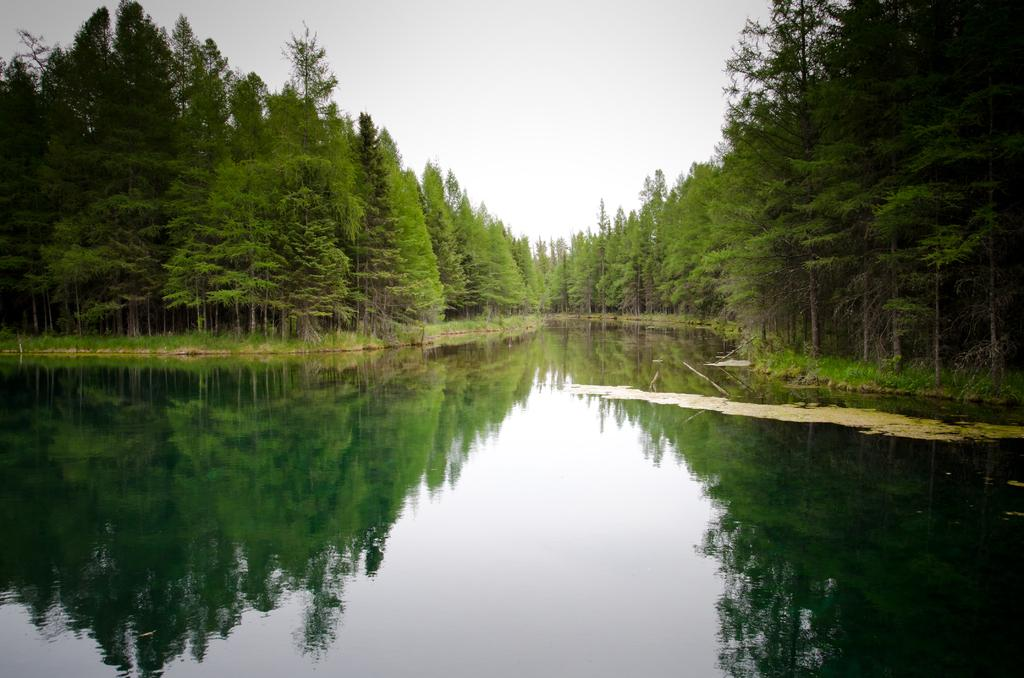What body of water is present in the image? There is a lake in the image. What type of vegetation surrounds the lake? There are trees on either side of the lake. What can be seen in the background of the image? The sky is visible in the background of the image. Where is the key to the station located in the image? There is no station or key present in the image. What is the top speed of the vehicle in the image? There is no vehicle present in the image. 